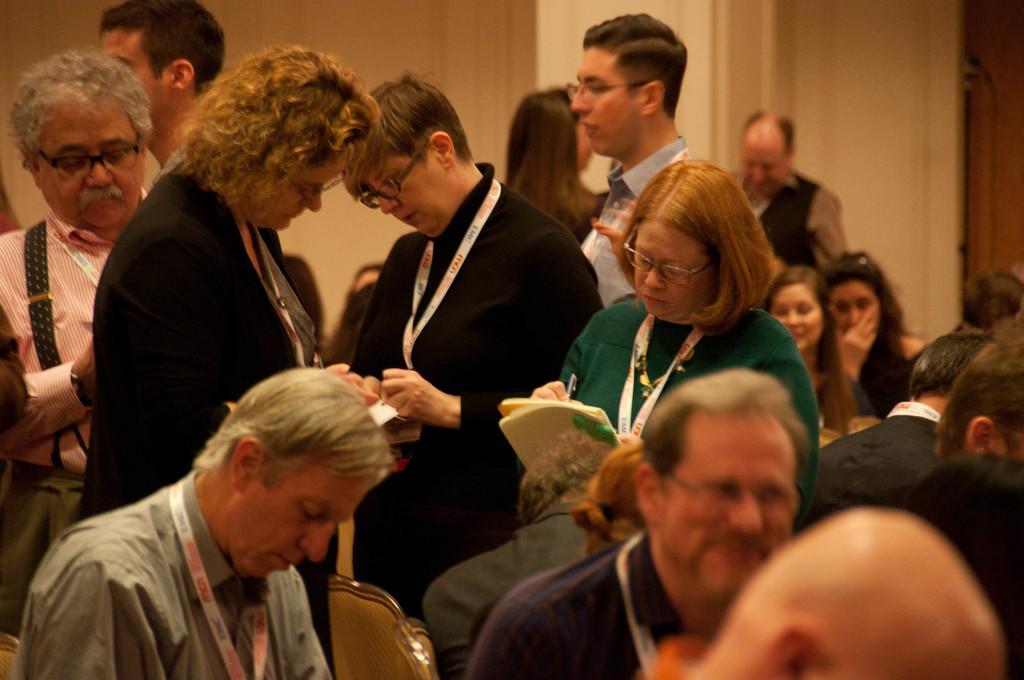Could you give a brief overview of what you see in this image? Here we can see a group of people. Few people are sitting and few people wore id cards. Background there is a wall. 